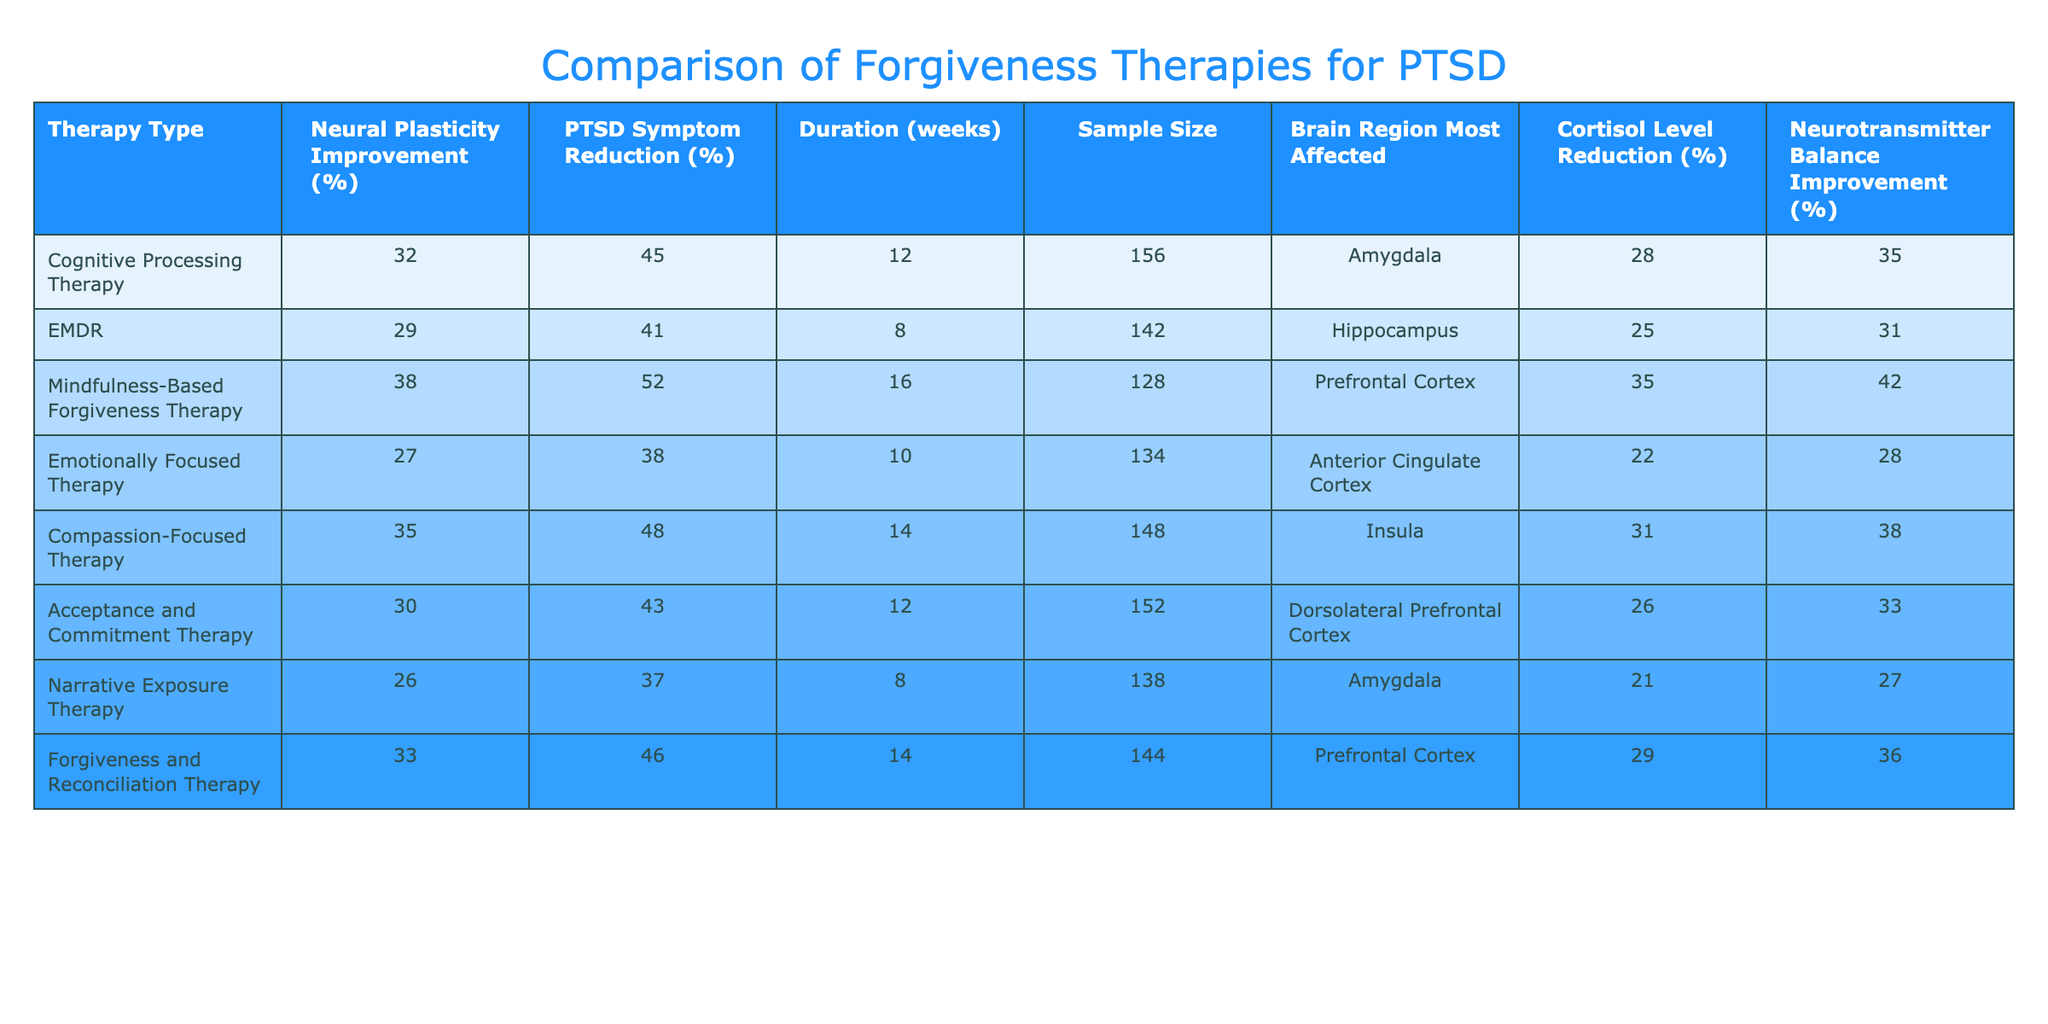What is the therapy type that resulted in the highest improvement in neural plasticity? By examining the "Neural Plasticity Improvement (%)" column, we see that "Mindfulness-Based Forgiveness Therapy" has the highest value of 38%.
Answer: Mindfulness-Based Forgiveness Therapy Which therapy showed the greatest reduction in PTSD symptoms? Looking at the "PTSD Symptom Reduction (%)" column, "Mindfulness-Based Forgiveness Therapy" again stands out with a reduction of 52%, the highest in the table.
Answer: Mindfulness-Based Forgiveness Therapy What is the average cortisol level reduction across all therapies listed? To find the average, we sum all the cortisol level reductions: (28 + 25 + 35 + 22 + 31 + 26 + 21 + 29) =  27.5 and divide by the number of therapies (8). So, the average reduction is approximately 27.5%.
Answer: 27.5% Is Compassion-Focused Therapy more effective than Acceptance and Commitment Therapy in terms of PTSD symptom reduction? Comparing the percentages in the "PTSD Symptom Reduction (%)" column, Compassion-Focused Therapy has a reduction of 48% while Acceptance and Commitment Therapy has 43%. This indicates that Compassion-Focused Therapy is indeed more effective based on this metric.
Answer: Yes Among therapies that affect the Prefrontal Cortex, which has a higher neural plasticity improvement? The therapies affecting the Prefrontal Cortex are "Mindfulness-Based Forgiveness Therapy" (38%) and "Forgiveness and Reconciliation Therapy" (33%). Since 38% is greater than 33%, Mindfulness-Based Forgiveness Therapy has a higher improvement.
Answer: Mindfulness-Based Forgiveness Therapy What is the therapy type with the largest sample size? By reviewing the "Sample Size" column, we note that "Cognitive Processing Therapy" has the highest sample size of 156 participants, which is greater than all other therapies listed.
Answer: Cognitive Processing Therapy Is there any therapy that shows an equal or better improvement in neurotransmitter balance compared to neural plasticity improvement? We analyze the "Neurotransmitter Balance Improvement (%)" against "Neural Plasticity Improvement (%)". "Mindfulness-Based Forgiveness Therapy" shows 42% improvement in neurotransmitter balance which is better than its neural plasticity improvement of 38%. Thus, it meets the criteria.
Answer: Yes Which brain region is most affected by Compassion-Focused Therapy? Referring to the "Brain Region Most Affected" column, Compassion-Focused Therapy specifies the Insula as the most affected region.
Answer: Insula 